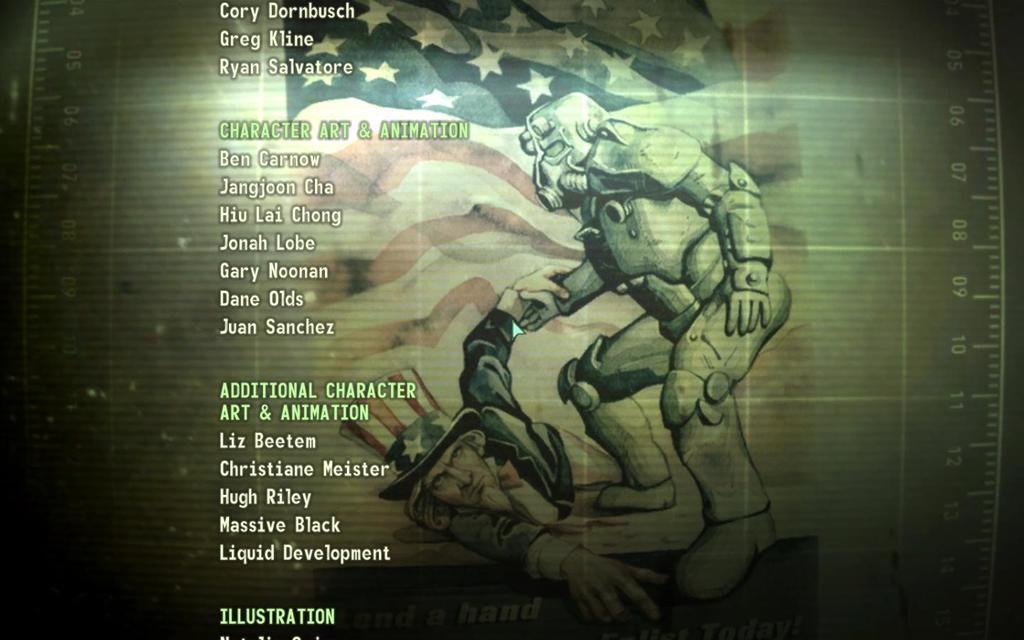What is bens last name?
Make the answer very short. Carnow. 